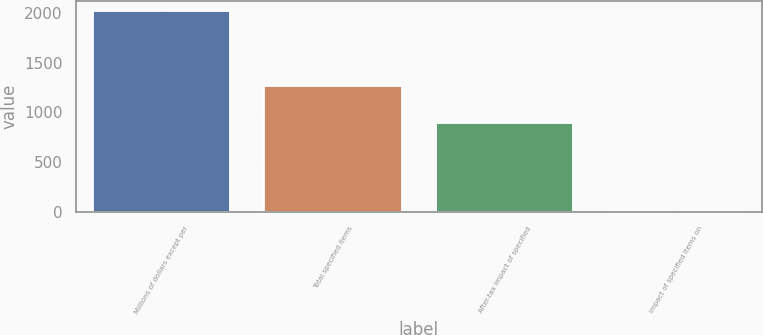Convert chart to OTSL. <chart><loc_0><loc_0><loc_500><loc_500><bar_chart><fcel>Millions of dollars except per<fcel>Total specified items<fcel>After-tax impact of specified<fcel>Impact of specified items on<nl><fcel>2016<fcel>1261<fcel>892<fcel>4.1<nl></chart> 